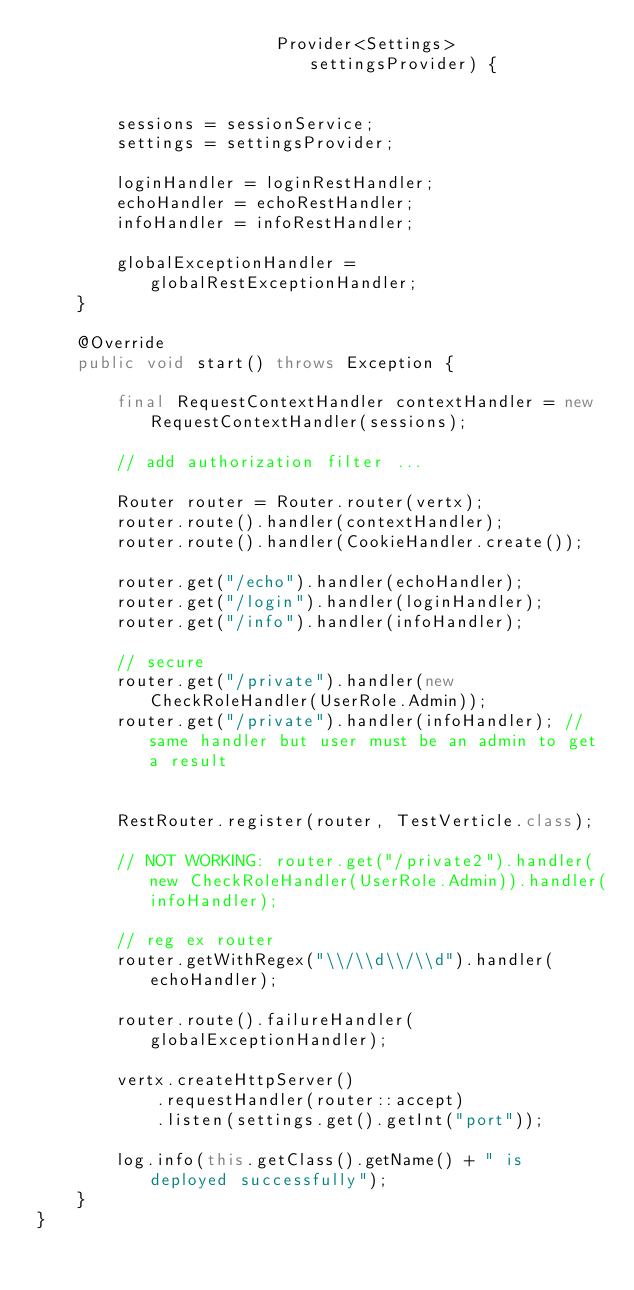<code> <loc_0><loc_0><loc_500><loc_500><_Java_>	                    Provider<Settings> settingsProvider) {


		sessions = sessionService;
		settings = settingsProvider;

		loginHandler = loginRestHandler;
		echoHandler = echoRestHandler;
		infoHandler = infoRestHandler;

		globalExceptionHandler = globalRestExceptionHandler;
	}

	@Override
	public void start() throws Exception {

		final RequestContextHandler contextHandler = new RequestContextHandler(sessions);

		// add authorization filter ...

		Router router = Router.router(vertx);
		router.route().handler(contextHandler);
		router.route().handler(CookieHandler.create());

		router.get("/echo").handler(echoHandler);
		router.get("/login").handler(loginHandler);
		router.get("/info").handler(infoHandler);

		// secure
		router.get("/private").handler(new CheckRoleHandler(UserRole.Admin));
		router.get("/private").handler(infoHandler); // same handler but user must be an admin to get a result


		RestRouter.register(router, TestVerticle.class);

		// NOT WORKING: router.get("/private2").handler(new CheckRoleHandler(UserRole.Admin)).handler(infoHandler);

		// reg ex router
		router.getWithRegex("\\/\\d\\/\\d").handler(echoHandler);

		router.route().failureHandler(globalExceptionHandler);

		vertx.createHttpServer()
			.requestHandler(router::accept)
			.listen(settings.get().getInt("port"));

		log.info(this.getClass().getName() + " is deployed successfully");
	}
}
</code> 